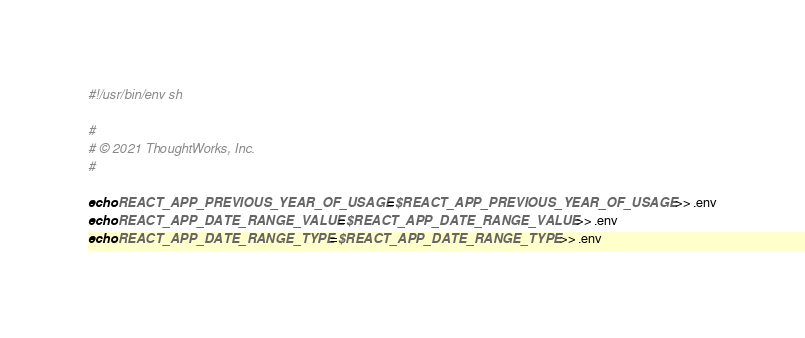Convert code to text. <code><loc_0><loc_0><loc_500><loc_500><_Bash_>#!/usr/bin/env sh

#
# © 2021 ThoughtWorks, Inc.
#

echo REACT_APP_PREVIOUS_YEAR_OF_USAGE=$REACT_APP_PREVIOUS_YEAR_OF_USAGE >> .env
echo REACT_APP_DATE_RANGE_VALUE=$REACT_APP_DATE_RANGE_VALUE >> .env
echo REACT_APP_DATE_RANGE_TYPE=$REACT_APP_DATE_RANGE_TYPE >> .env
</code> 